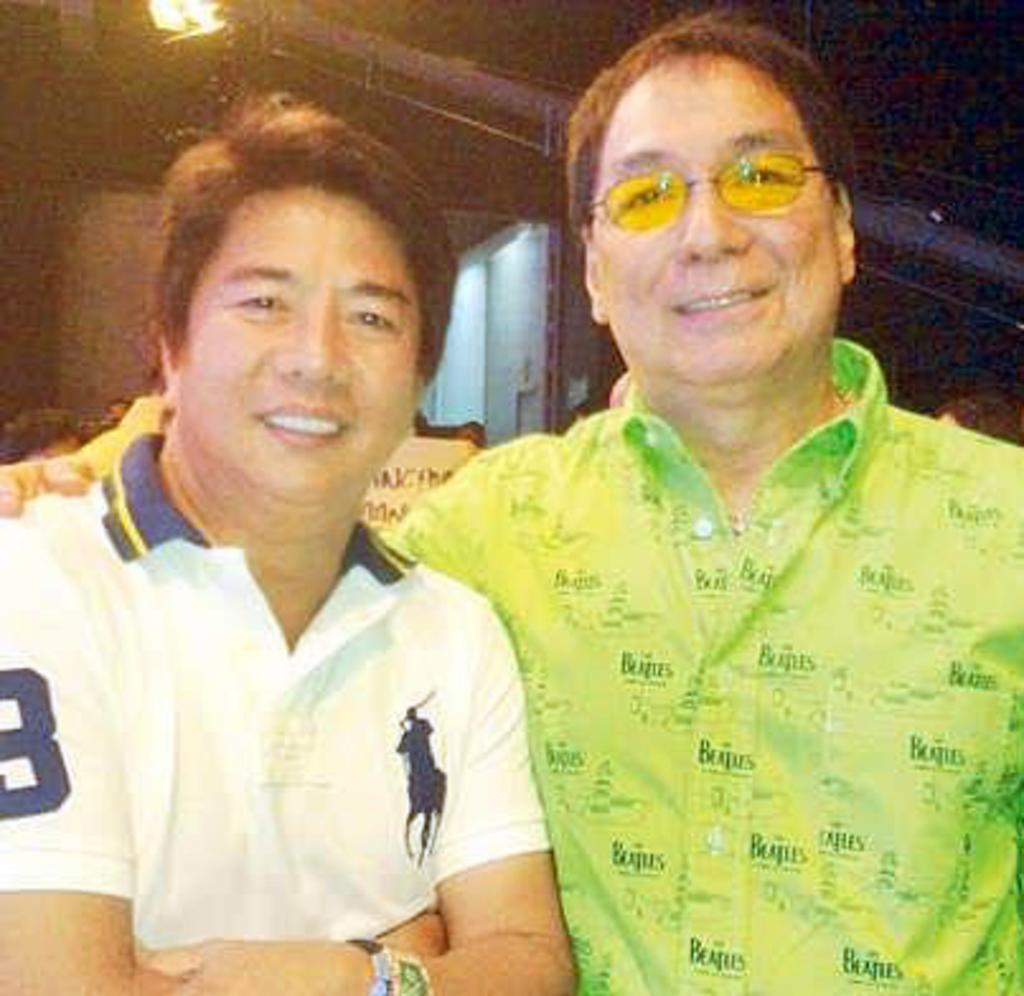How many people are in the image? There are people in the image, but the exact number is not specified. Can you describe any specific features of one of the people? One person is wearing glasses. What can be seen in the background of the image? There is a light and rods visible in the background of the image. What type of plastic is being used to plough the field in the image? There is no plough or field present in the image, so it is not possible to determine what type of plastic might be used. 